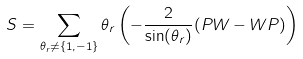<formula> <loc_0><loc_0><loc_500><loc_500>S = \sum _ { \theta _ { r } \neq \{ 1 , - 1 \} } \theta _ { r } \left ( - \frac { 2 } { \sin ( \theta _ { r } ) } ( P W - W P ) \right )</formula> 